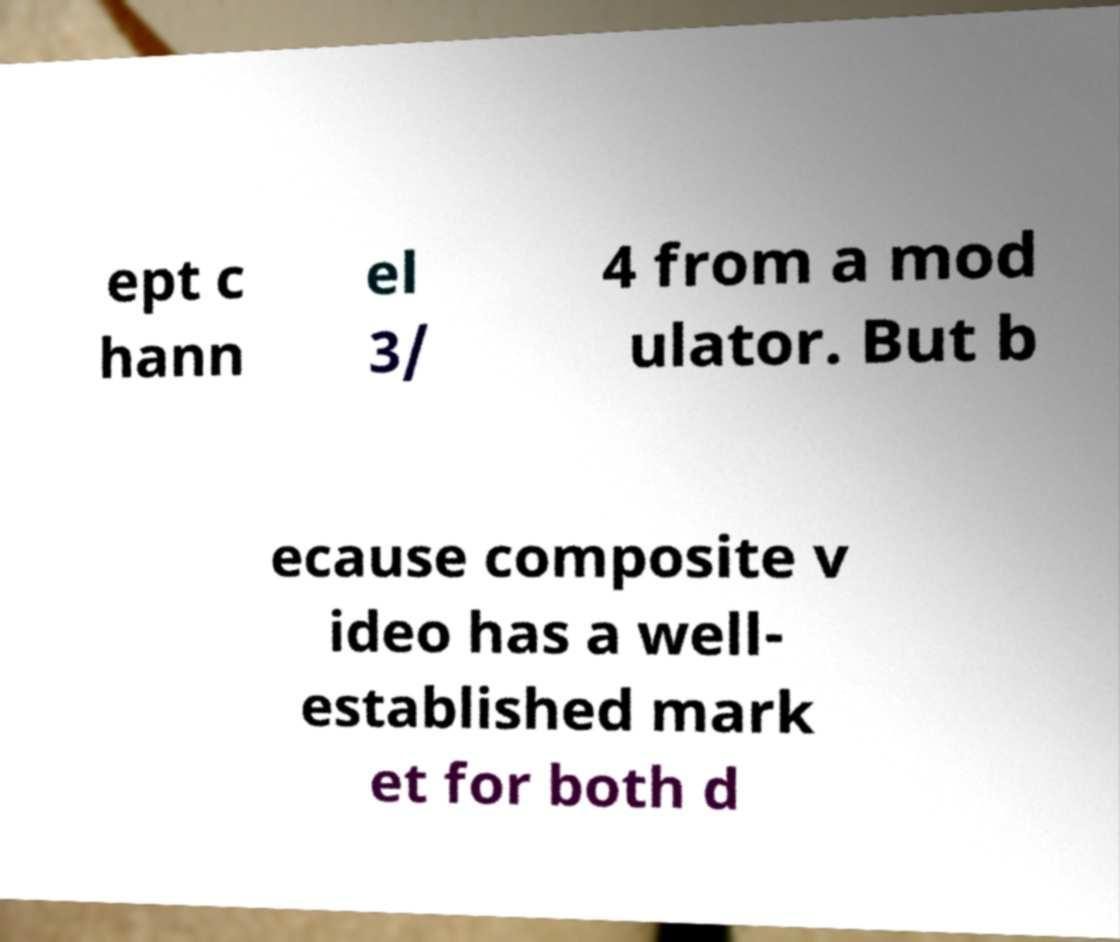For documentation purposes, I need the text within this image transcribed. Could you provide that? ept c hann el 3/ 4 from a mod ulator. But b ecause composite v ideo has a well- established mark et for both d 